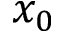Convert formula to latex. <formula><loc_0><loc_0><loc_500><loc_500>x _ { 0 }</formula> 